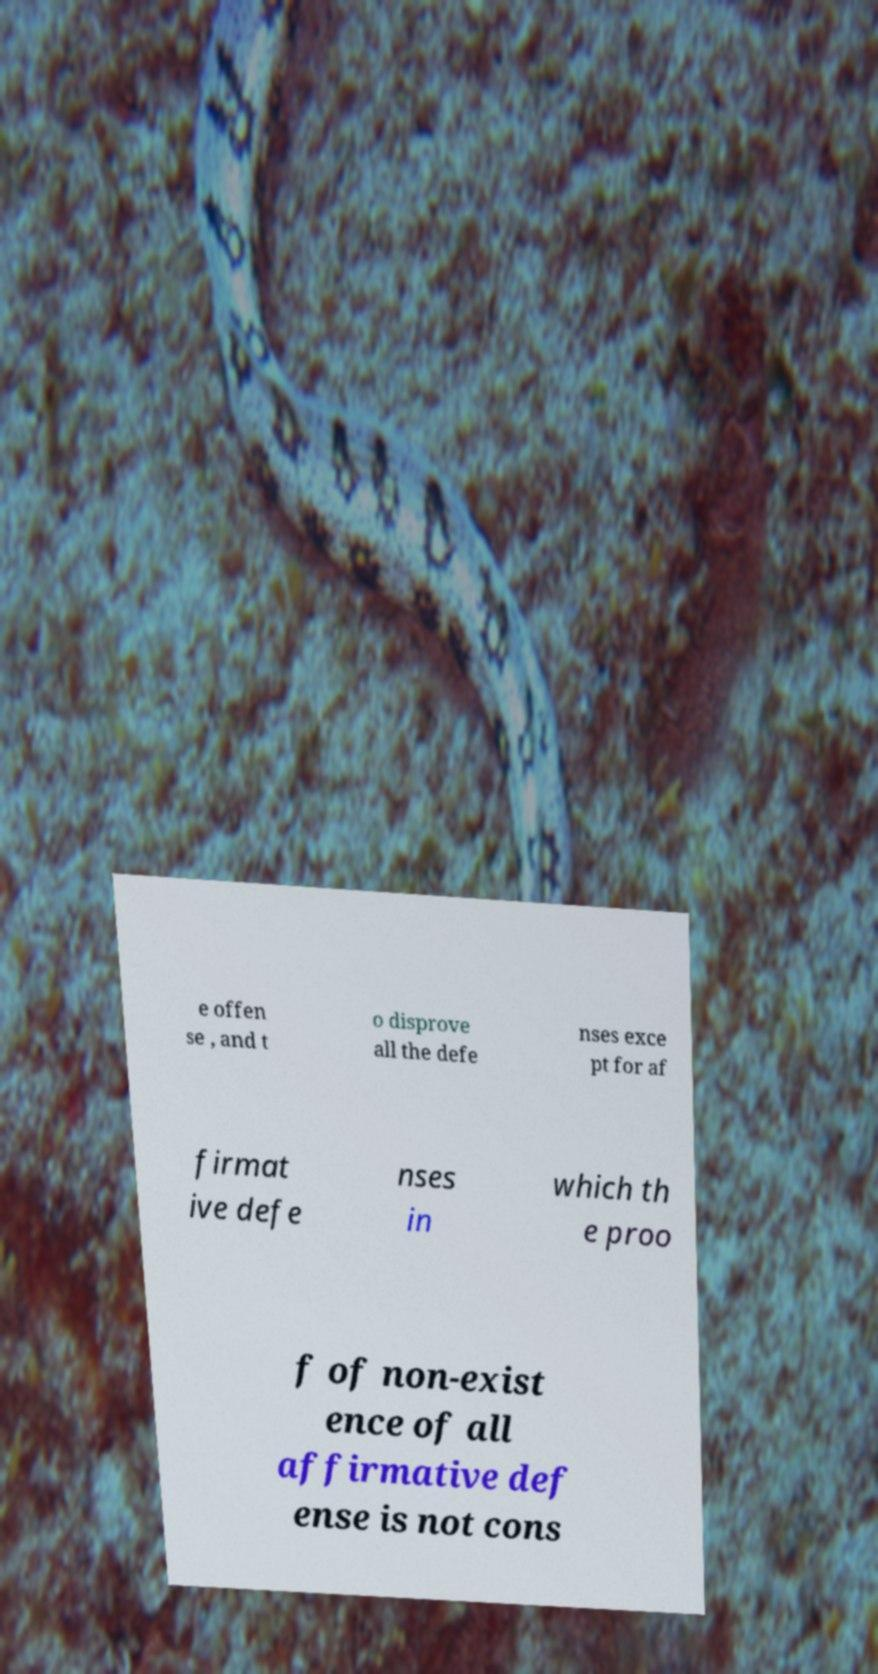For documentation purposes, I need the text within this image transcribed. Could you provide that? e offen se , and t o disprove all the defe nses exce pt for af firmat ive defe nses in which th e proo f of non-exist ence of all affirmative def ense is not cons 